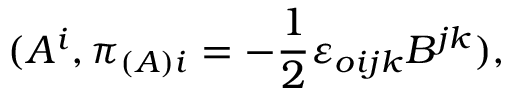<formula> <loc_0><loc_0><loc_500><loc_500>( A ^ { i } , \pi _ { ( A ) i } = - \frac { 1 } { 2 } { \varepsilon } _ { o i j k } B ^ { j k } ) ,</formula> 